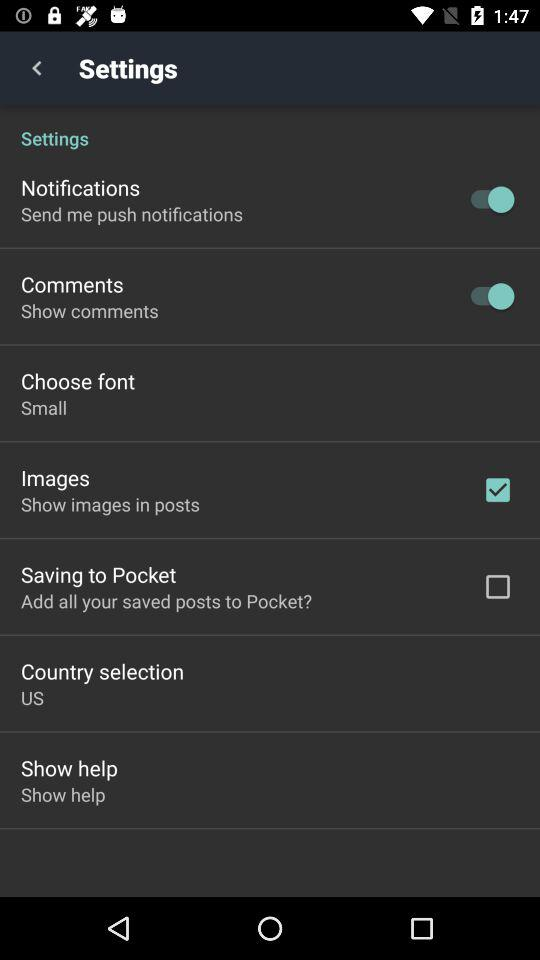Which buttons are turned on in the application? The turned on buttons in the applications are "Notifications" and "Comments". 